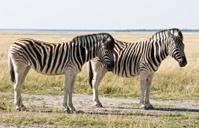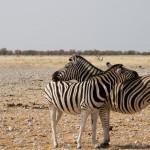The first image is the image on the left, the second image is the image on the right. Examine the images to the left and right. Is the description "One image shows two zebra standing in profile turned toward one another, each one with its head over the back of the other." accurate? Answer yes or no. Yes. The first image is the image on the left, the second image is the image on the right. Examine the images to the left and right. Is the description "The image on the right shows two zebras embracing each other with their heads." accurate? Answer yes or no. Yes. 